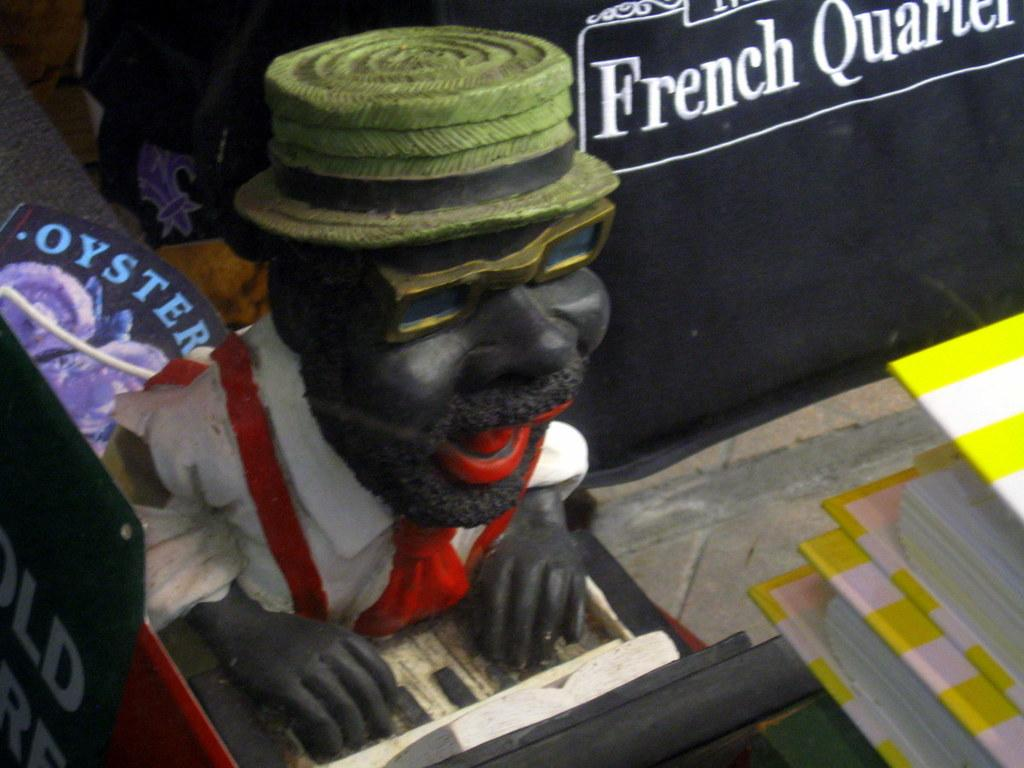What is the main subject of the image? There is a statue of a person in the image. Where is the statue located? The statue is on a platform. What else can be seen in the image besides the statue? There are boards visible in the image. Are there any objects near the statue or on the platform? Yes, there are some objects on the platform or near the statue. What type of rhythm can be heard coming from the statue in the image? There is no sound or rhythm associated with the statue in the image. 